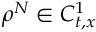Convert formula to latex. <formula><loc_0><loc_0><loc_500><loc_500>\rho ^ { N } \in C _ { t , x } ^ { 1 }</formula> 